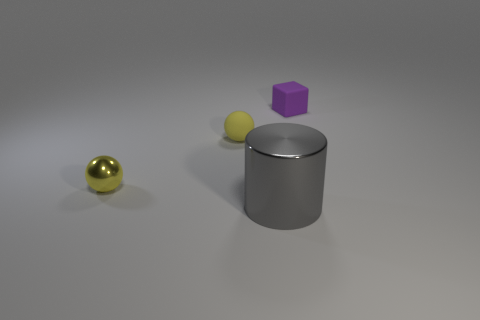Add 1 big green metallic cylinders. How many objects exist? 5 Subtract all cylinders. How many objects are left? 3 Subtract all yellow things. Subtract all gray metal objects. How many objects are left? 1 Add 3 purple matte cubes. How many purple matte cubes are left? 4 Add 2 small purple cubes. How many small purple cubes exist? 3 Subtract 0 red spheres. How many objects are left? 4 